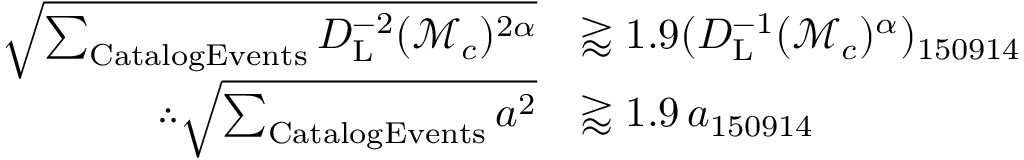<formula> <loc_0><loc_0><loc_500><loc_500>\begin{array} { r l } { \sqrt { \sum _ { C a t a \log E v e n t s } D _ { L } ^ { - 2 } ( \mathcal { M } _ { c } ) ^ { 2 \alpha } } } & { \gtrapprox 1 . 9 ( D _ { L } ^ { - 1 } ( \mathcal { M } _ { c } ) ^ { \alpha } ) _ { 1 5 0 9 1 4 } } \\ { \therefore \sqrt { \sum _ { C a t a \log E v e n t s } a ^ { 2 } } } & { \gtrapprox 1 . 9 \, a _ { 1 5 0 9 1 4 } } \end{array}</formula> 